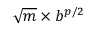<formula> <loc_0><loc_0><loc_500><loc_500>{ \sqrt { m } } \times b ^ { p / 2 }</formula> 